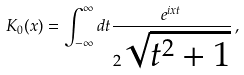Convert formula to latex. <formula><loc_0><loc_0><loc_500><loc_500>K _ { 0 } ( x ) = \int _ { - \infty } ^ { \infty } d t \frac { e ^ { i x t } } { 2 \sqrt { t ^ { 2 } + 1 } } \, ,</formula> 